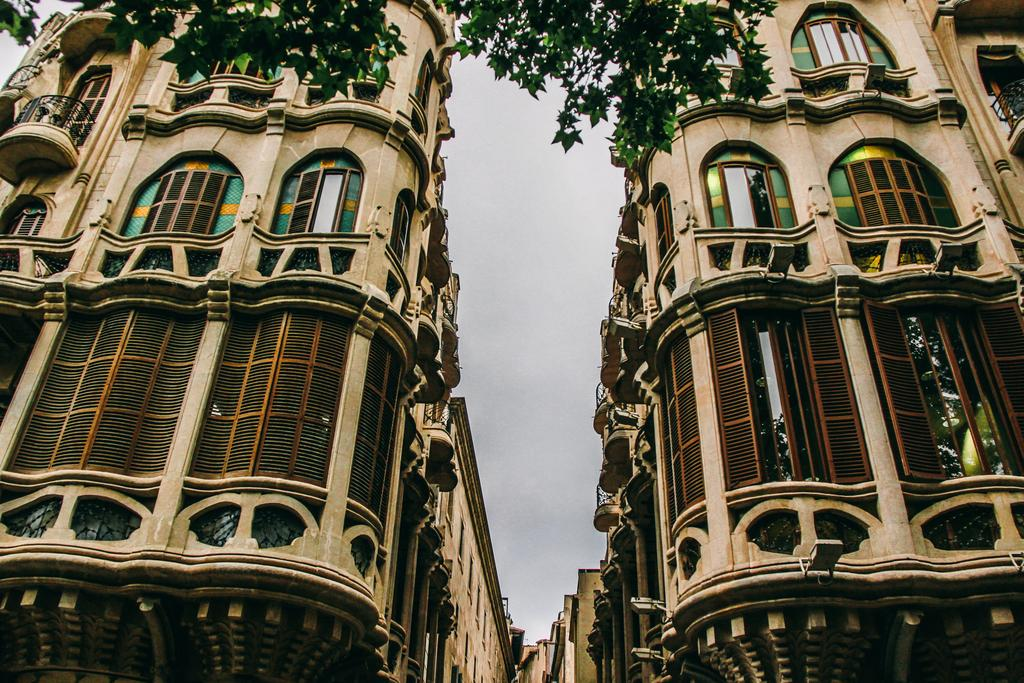What type of structures can be seen in the image? There are buildings in the image. What can be seen illuminated in the image? There are lights visible in the image. What architectural features are present in the buildings? There are windows in the image. What type of vegetation is present in the image? There are trees in the image. What is visible at the top of the image? The sky is visible at the top of the image. What type of competition is being held in the image? There is no competition present in the image. What type of system is being used to organize the buildings in the image? There is no system being used to organize the buildings in the image; they are simply depicted as they are. 